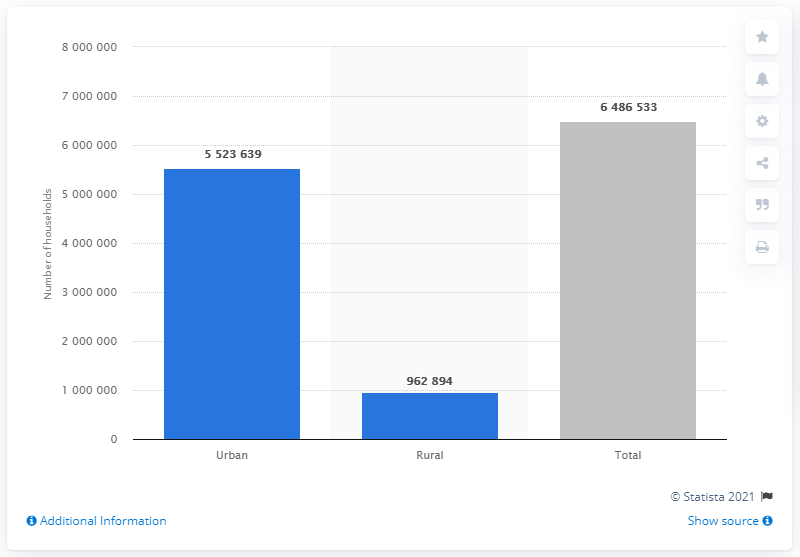Can you describe the difference in household distribution between urban and rural areas in Chile? Certainly, the image shows a stark contrast in household distribution in Chile, with 5,523,639 households in urban areas compared to 962,894 in rural regions. This reflects a trend where a larger portion of the population prefers or requires the amenities found in urban centers. 